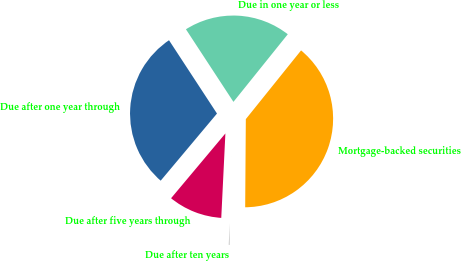Convert chart to OTSL. <chart><loc_0><loc_0><loc_500><loc_500><pie_chart><fcel>Due in one year or less<fcel>Due after one year through<fcel>Due after five years through<fcel>Due after ten years<fcel>Mortgage-backed securities<nl><fcel>20.0%<fcel>29.67%<fcel>10.33%<fcel>0.66%<fcel>39.34%<nl></chart> 